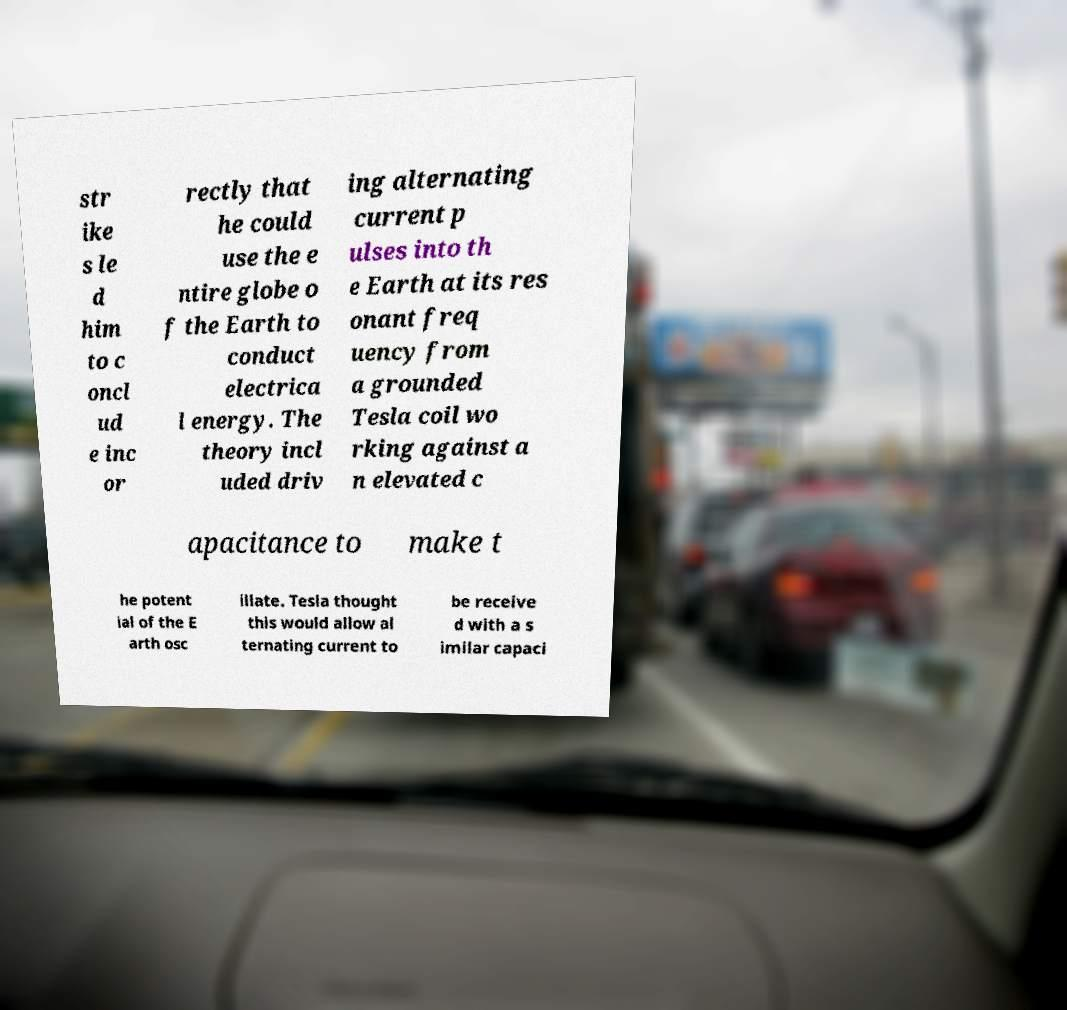What messages or text are displayed in this image? I need them in a readable, typed format. str ike s le d him to c oncl ud e inc or rectly that he could use the e ntire globe o f the Earth to conduct electrica l energy. The theory incl uded driv ing alternating current p ulses into th e Earth at its res onant freq uency from a grounded Tesla coil wo rking against a n elevated c apacitance to make t he potent ial of the E arth osc illate. Tesla thought this would allow al ternating current to be receive d with a s imilar capaci 